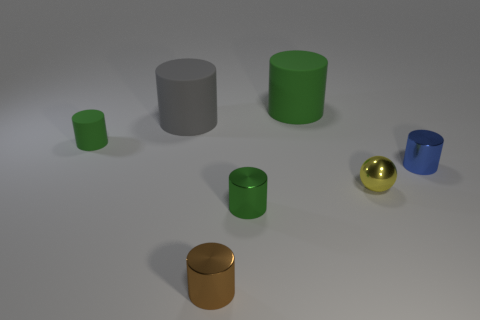What number of small rubber objects have the same color as the small ball?
Offer a terse response. 0. What is the green thing behind the matte object that is in front of the big matte cylinder that is left of the brown metal cylinder made of?
Offer a very short reply. Rubber. How many yellow things are either small things or small matte spheres?
Your response must be concise. 1. What is the size of the rubber object that is to the right of the small green cylinder in front of the small green cylinder on the left side of the gray rubber thing?
Your answer should be very brief. Large. There is a gray object that is the same shape as the small green matte thing; what size is it?
Provide a succinct answer. Large. What number of small objects are gray rubber cylinders or metal cylinders?
Keep it short and to the point. 3. Does the tiny cylinder in front of the small green metallic cylinder have the same material as the big gray thing that is behind the shiny ball?
Offer a terse response. No. What material is the big object to the left of the big green thing?
Offer a very short reply. Rubber. How many rubber objects are big green things or tiny brown cubes?
Ensure brevity in your answer.  1. There is a large rubber cylinder that is to the left of the rubber object to the right of the brown shiny object; what color is it?
Your response must be concise. Gray. 